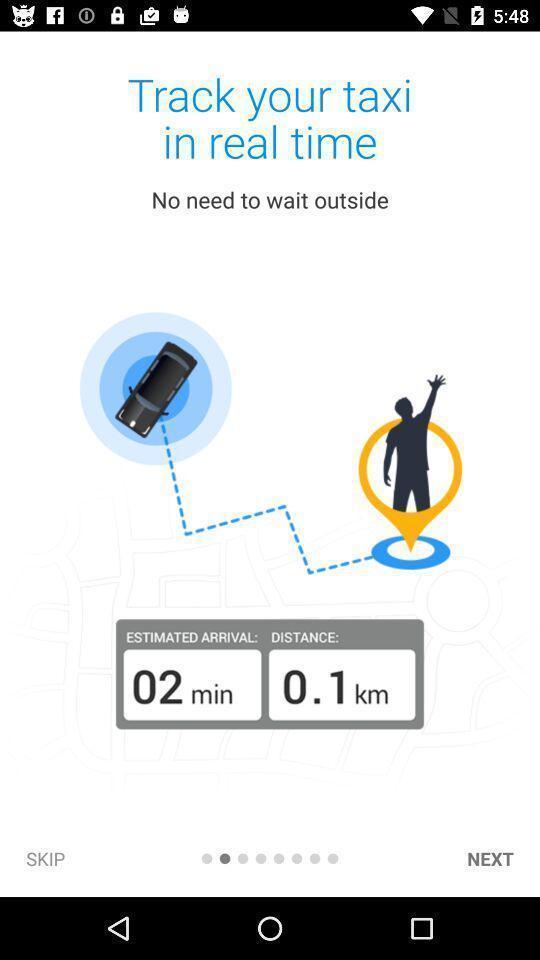Provide a description of this screenshot. Taxi track application in the mobile. 